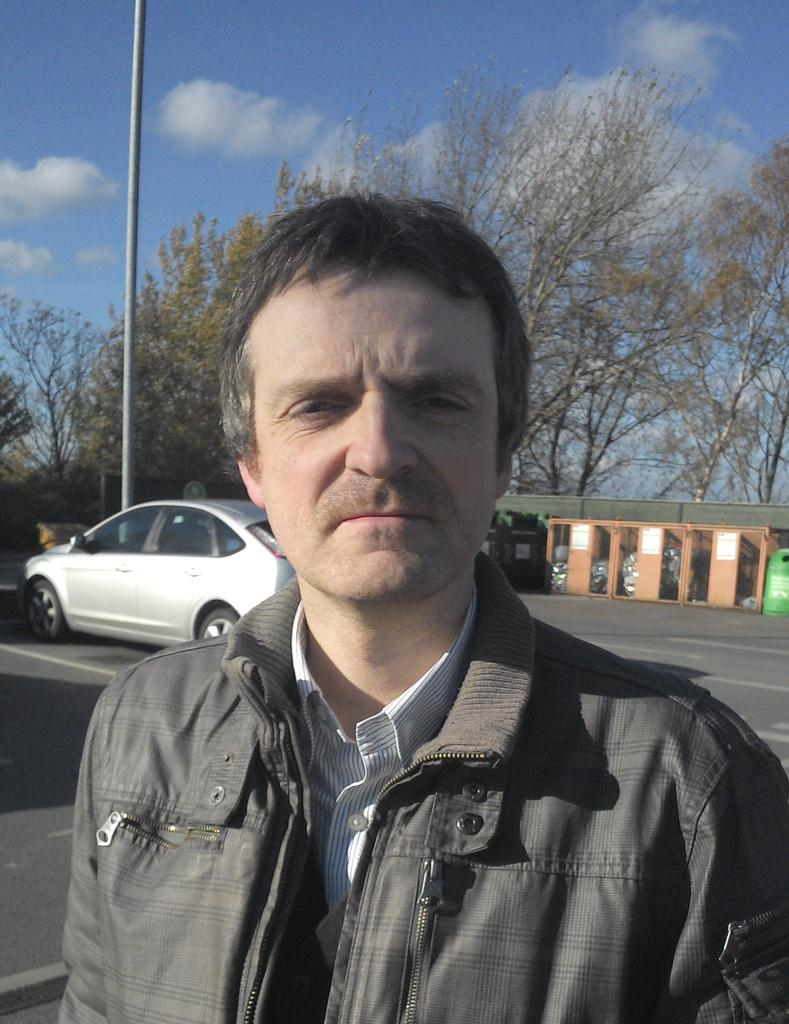Who is present in the image? There is a man in the image. What is the man wearing? The man is wearing clothes. What can be seen on the road in the image? There is a vehicle on the road in the image. What is the tall, vertical object in the image? There is a pole in the image. What type of vegetation is visible in the image? There are trees in the image. How would you describe the sky in the image? The sky is cloudy and pale blue in the image. What type of camera is the man using to take pictures of the office in the image? There is no camera or office present in the image; it only features a man, a vehicle, a pole, trees, and a cloudy, pale blue sky. 